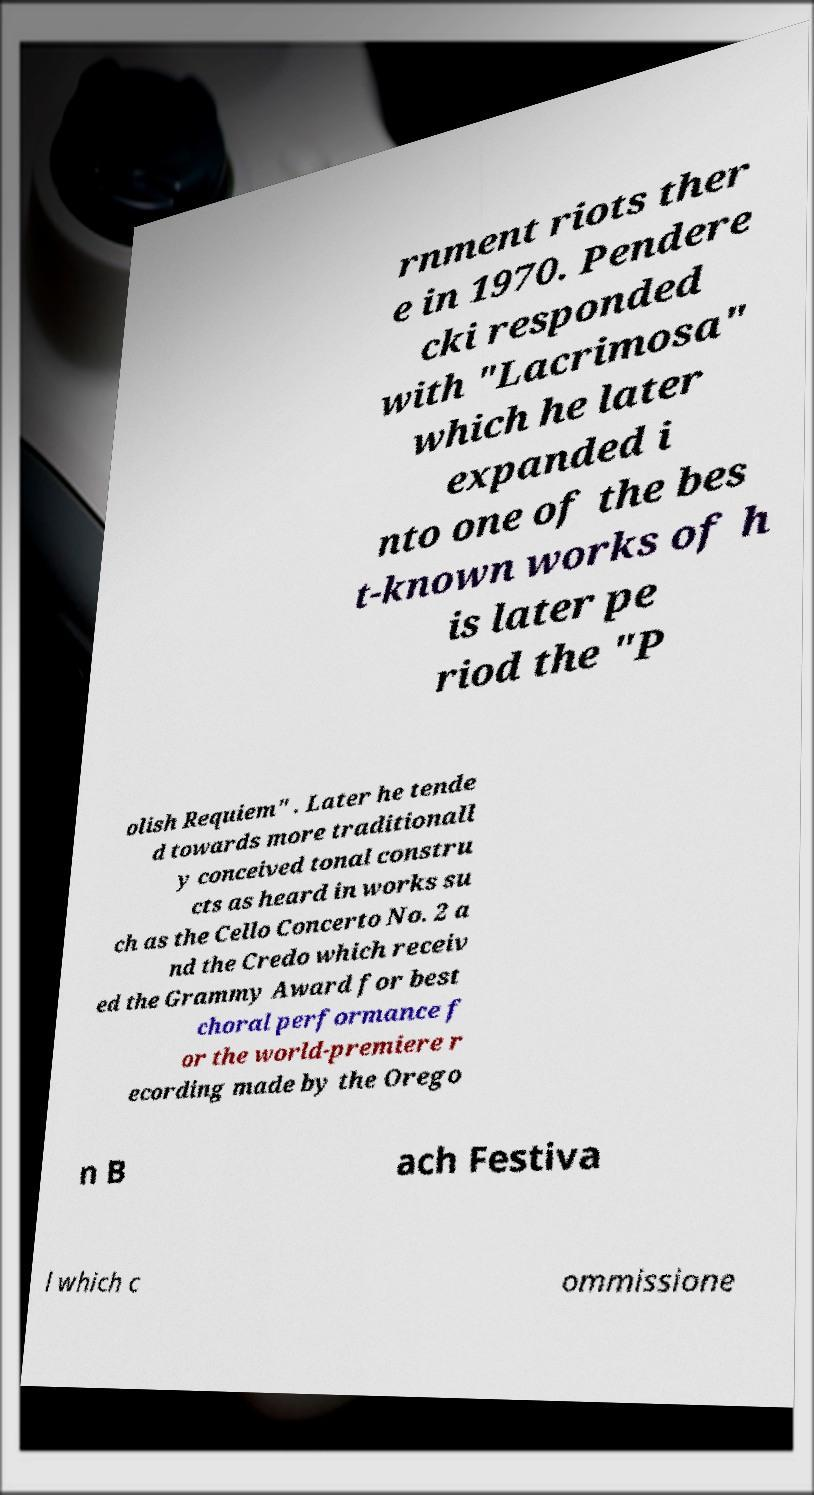Could you assist in decoding the text presented in this image and type it out clearly? rnment riots ther e in 1970. Pendere cki responded with "Lacrimosa" which he later expanded i nto one of the bes t-known works of h is later pe riod the "P olish Requiem" . Later he tende d towards more traditionall y conceived tonal constru cts as heard in works su ch as the Cello Concerto No. 2 a nd the Credo which receiv ed the Grammy Award for best choral performance f or the world-premiere r ecording made by the Orego n B ach Festiva l which c ommissione 